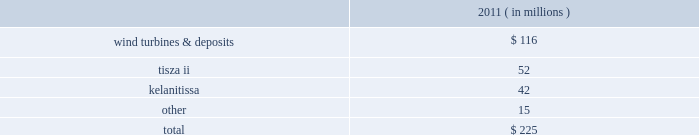The aes corporation notes to consolidated financial statements 2014 ( continued ) december 31 , 2011 , 2010 , and 2009 20 .
Impairment expense asset impairment asset impairment expense for the year ended december 31 , 2011 consisted of : ( in millions ) .
Wind turbines & deposits 2014during the third quarter of 2011 , the company evaluated the future use of certain wind turbines held in storage pending their installation .
Due to reduced wind turbine market pricing and advances in turbine technology , the company determined it was more likely than not that the turbines would be sold significantly before the end of their previously estimated useful lives .
In addition , the company has concluded that more likely than not non-refundable deposits it had made in prior years to a turbine manufacturer for the purchase of wind turbines are not recoverable .
The company determined it was more likely than not that it would not proceed with the purchase of turbines due to the availability of more advanced and lower cost turbines in the market .
These developments were more likely than not as of september 30 , 2011 and as a result were considered impairment indicators and the company determined that an impairment had occurred as of september 30 , 2011 as the aggregate carrying amount of $ 161 million of these assets was not recoverable and was reduced to their estimated fair value of $ 45 million determined under the market approach .
This resulted in asset impairment expense of $ 116 million .
Wind generation is reported in the corporate and other segment .
In january 2012 , the company forfeited the deposits for which a full impairment charge was recognized in the third quarter of 2011 , and there is no obligation for further payments under the related turbine supply agreement .
Additionally , the company sold some of the turbines held in storage during the fourth quarter of 2011 and is continuing to evaluate the future use of the turbines held in storage .
The company determined it is more likely than not that they will be sold , however they are not being actively marketed for sale at this time as the company is reconsidering the potential use of the turbines in light of recent development activity at one of its advance stage development projects .
It is reasonably possible that the turbines could incur further loss in value due to changing market conditions and advances in technology .
Tisza ii 2014during the fourth quarter of 2011 , tisza ii , a 900 mw gas and oil-fired generation plant in hungary entered into annual negotiations with its offtaker .
As a result of these negotiations , as well as the further deterioration of the economic environment in hungary , the company determined that an indicator of impairment existed at december 31 , 2011 .
Thus , the company performed an asset impairment test and determined that based on the undiscounted cash flow analysis , the carrying amount of tisza ii asset group was not recoverable .
The fair value of the asset group was then determined using a discounted cash flow analysis .
The carrying value of the tisza ii asset group of $ 94 million exceeded the fair value of $ 42 million resulting in the recognition of asset impairment expense of $ 52 million during the three months ended december 31 , 2011 .
Tisza ii is reported in the europe generation reportable segment .
Kelanitissa 2014in 2011 , the company recognized asset impairment expense of $ 42 million for the long-lived assets of kelanitissa , our diesel-fired generation plant in sri lanka .
We have continued to evaluate the recoverability of our long-lived assets at kelanitissa as a result of both the existing government regulation which .
What percentage of asset impairment expense for the year ended december 31 , 2011 was related to wind turbines & deposits? 
Computations: (116 / 225)
Answer: 0.51556. The aes corporation notes to consolidated financial statements 2014 ( continued ) december 31 , 2011 , 2010 , and 2009 20 .
Impairment expense asset impairment asset impairment expense for the year ended december 31 , 2011 consisted of : ( in millions ) .
Wind turbines & deposits 2014during the third quarter of 2011 , the company evaluated the future use of certain wind turbines held in storage pending their installation .
Due to reduced wind turbine market pricing and advances in turbine technology , the company determined it was more likely than not that the turbines would be sold significantly before the end of their previously estimated useful lives .
In addition , the company has concluded that more likely than not non-refundable deposits it had made in prior years to a turbine manufacturer for the purchase of wind turbines are not recoverable .
The company determined it was more likely than not that it would not proceed with the purchase of turbines due to the availability of more advanced and lower cost turbines in the market .
These developments were more likely than not as of september 30 , 2011 and as a result were considered impairment indicators and the company determined that an impairment had occurred as of september 30 , 2011 as the aggregate carrying amount of $ 161 million of these assets was not recoverable and was reduced to their estimated fair value of $ 45 million determined under the market approach .
This resulted in asset impairment expense of $ 116 million .
Wind generation is reported in the corporate and other segment .
In january 2012 , the company forfeited the deposits for which a full impairment charge was recognized in the third quarter of 2011 , and there is no obligation for further payments under the related turbine supply agreement .
Additionally , the company sold some of the turbines held in storage during the fourth quarter of 2011 and is continuing to evaluate the future use of the turbines held in storage .
The company determined it is more likely than not that they will be sold , however they are not being actively marketed for sale at this time as the company is reconsidering the potential use of the turbines in light of recent development activity at one of its advance stage development projects .
It is reasonably possible that the turbines could incur further loss in value due to changing market conditions and advances in technology .
Tisza ii 2014during the fourth quarter of 2011 , tisza ii , a 900 mw gas and oil-fired generation plant in hungary entered into annual negotiations with its offtaker .
As a result of these negotiations , as well as the further deterioration of the economic environment in hungary , the company determined that an indicator of impairment existed at december 31 , 2011 .
Thus , the company performed an asset impairment test and determined that based on the undiscounted cash flow analysis , the carrying amount of tisza ii asset group was not recoverable .
The fair value of the asset group was then determined using a discounted cash flow analysis .
The carrying value of the tisza ii asset group of $ 94 million exceeded the fair value of $ 42 million resulting in the recognition of asset impairment expense of $ 52 million during the three months ended december 31 , 2011 .
Tisza ii is reported in the europe generation reportable segment .
Kelanitissa 2014in 2011 , the company recognized asset impairment expense of $ 42 million for the long-lived assets of kelanitissa , our diesel-fired generation plant in sri lanka .
We have continued to evaluate the recoverability of our long-lived assets at kelanitissa as a result of both the existing government regulation which .
What percentage of asset impairment expense for the year ended december 31 , 2011 was related to tisza ii? 
Computations: (52 / 225)
Answer: 0.23111. 